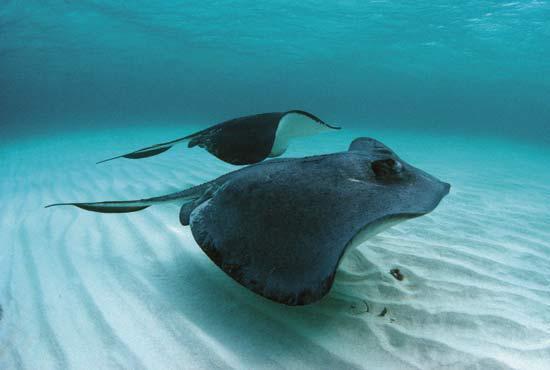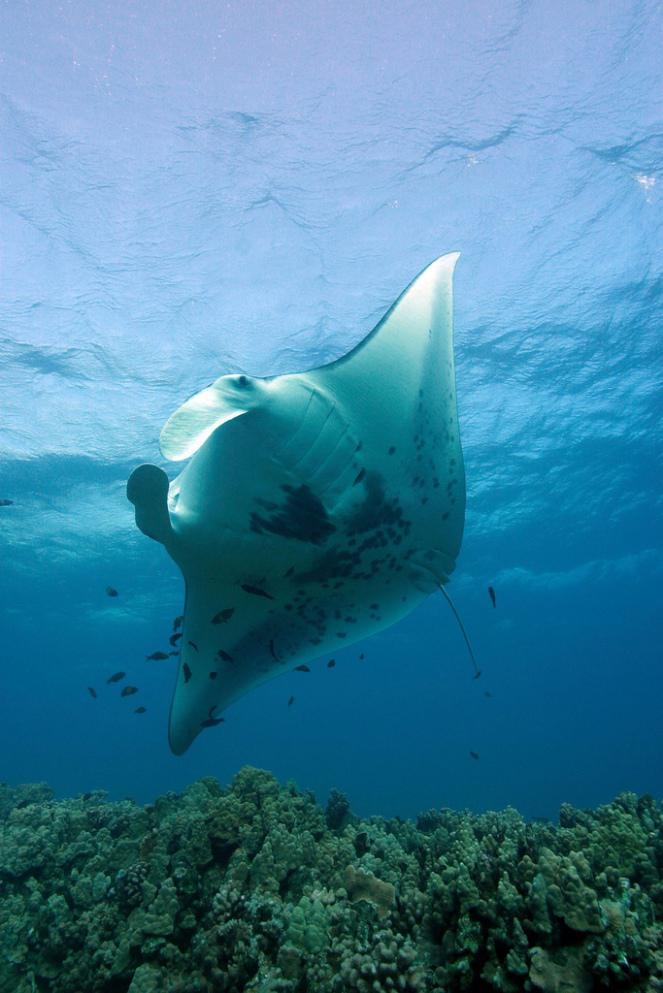The first image is the image on the left, the second image is the image on the right. For the images shown, is this caption "An image shows exactly two dark stingrays, including at least one that is nearly black." true? Answer yes or no. Yes. 